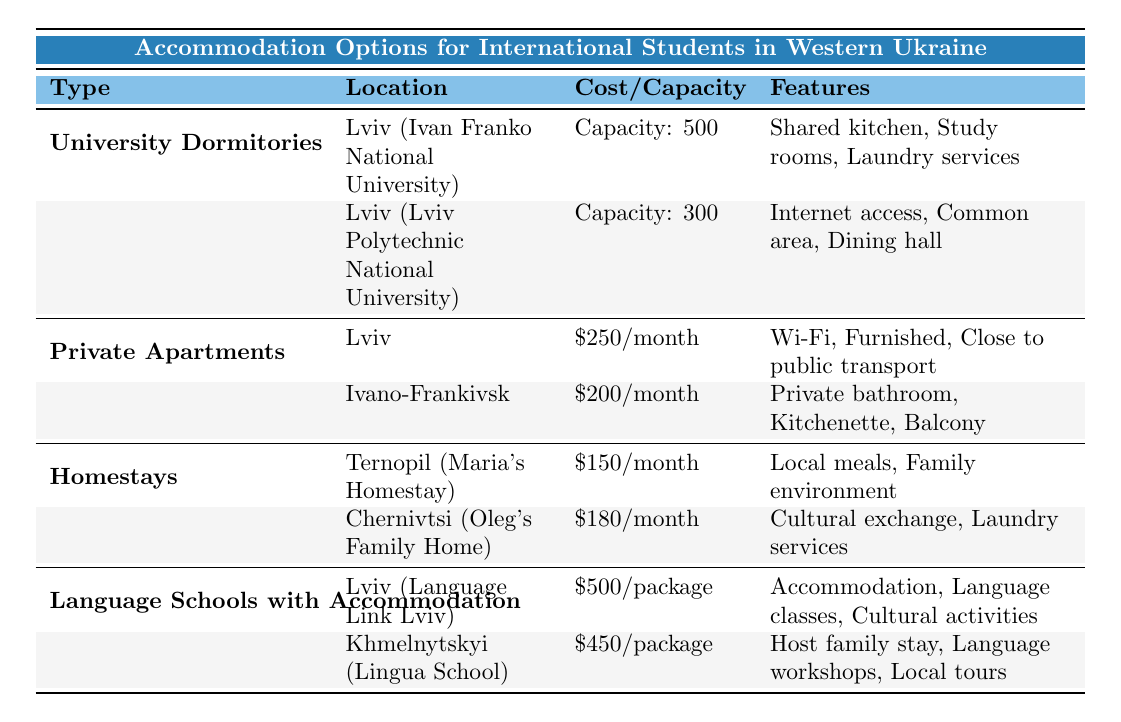What is the capacity of the university dormitory at Ivan Franko National University? The table lists the details for the university dormitories. Under the row for Ivan Franko National University in Lviv, it states that the capacity is 500.
Answer: 500 What amenities are provided in private apartments in Lviv? In the table under 'Private Apartments,' it specifies for Lviv that the amenities include Wi-Fi, Furnished, and Close to public transport.
Answer: Wi-Fi, Furnished, Close to public transport Which accommodation option has the lowest monthly cost listed? The table shows different accommodation options with their costs. The homestay option, specifically Maria's Homestay in Ternopil, lists a monthly cost of 150, which is the lowest compared to other options.
Answer: 150 How many total types of accommodation options are listed in the table? The table categorizes accommodation into four types: University Dormitories, Private Apartments, Homestays, and Language Schools with Accommodation. Counting these gives us a total of four types.
Answer: 4 What is the average monthly rent for private apartments in Lviv and Ivano-Frankivsk? From the table, the rent for Lviv is 250, and for Ivano-Frankivsk, it is 200. To find the average, sum both rents (250 + 200 = 450) and divide by the number of locations (2), yielding 450/2 = 225.
Answer: 225 Is there laundry service available in Maria's Homestay? The table specifies that Maria's Homestay offers a family environment and local meals, but it does not mention laundry services. Therefore, it is false that laundry service is available there.
Answer: No Which language school offers a package that includes cultural activities? The table lists the Language Link Lviv in Lviv, which includes Accommodation, Language classes, and Cultural activities in its package. Hence, this school offers the said package.
Answer: Language Link Lviv Which city has a higher average monthly rent for private apartments, Lviv or Ivano-Frankivsk? The table shows that private apartments in Lviv cost 250 while those in Ivano-Frankivsk cost 200. By comparing these two amounts, Lviv has the higher rent.
Answer: Lviv What features does Oleg's Family Home offer? The table states that Oleg's Family Home in Chernivtsi offers features of cultural exchange and laundry services. Therefore, these are the features of this homestay.
Answer: Cultural exchange, Laundry services 